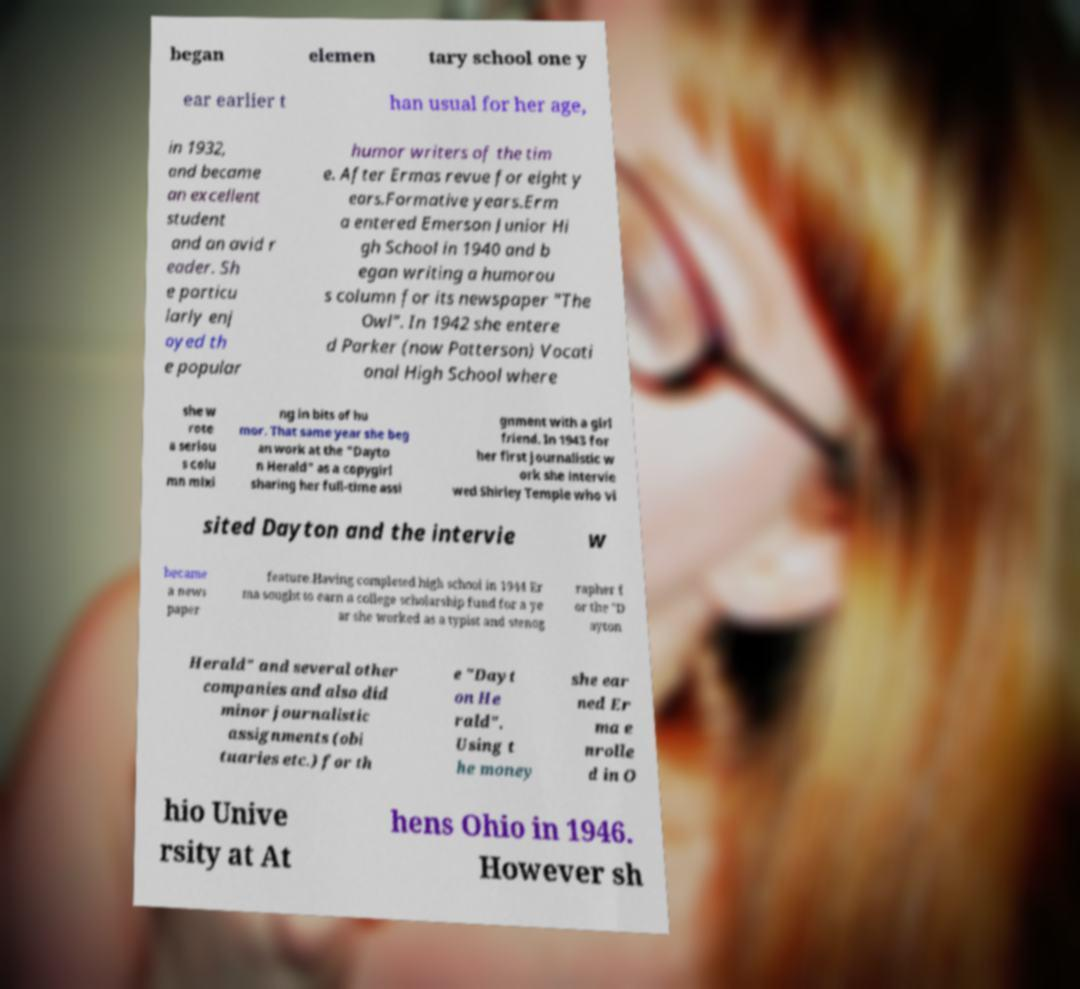Please read and relay the text visible in this image. What does it say? began elemen tary school one y ear earlier t han usual for her age, in 1932, and became an excellent student and an avid r eader. Sh e particu larly enj oyed th e popular humor writers of the tim e. After Ermas revue for eight y ears.Formative years.Erm a entered Emerson Junior Hi gh School in 1940 and b egan writing a humorou s column for its newspaper "The Owl". In 1942 she entere d Parker (now Patterson) Vocati onal High School where she w rote a seriou s colu mn mixi ng in bits of hu mor. That same year she beg an work at the "Dayto n Herald" as a copygirl sharing her full-time assi gnment with a girl friend. In 1943 for her first journalistic w ork she intervie wed Shirley Temple who vi sited Dayton and the intervie w became a news paper feature.Having completed high school in 1944 Er ma sought to earn a college scholarship fund for a ye ar she worked as a typist and stenog rapher f or the "D ayton Herald" and several other companies and also did minor journalistic assignments (obi tuaries etc.) for th e "Dayt on He rald". Using t he money she ear ned Er ma e nrolle d in O hio Unive rsity at At hens Ohio in 1946. However sh 